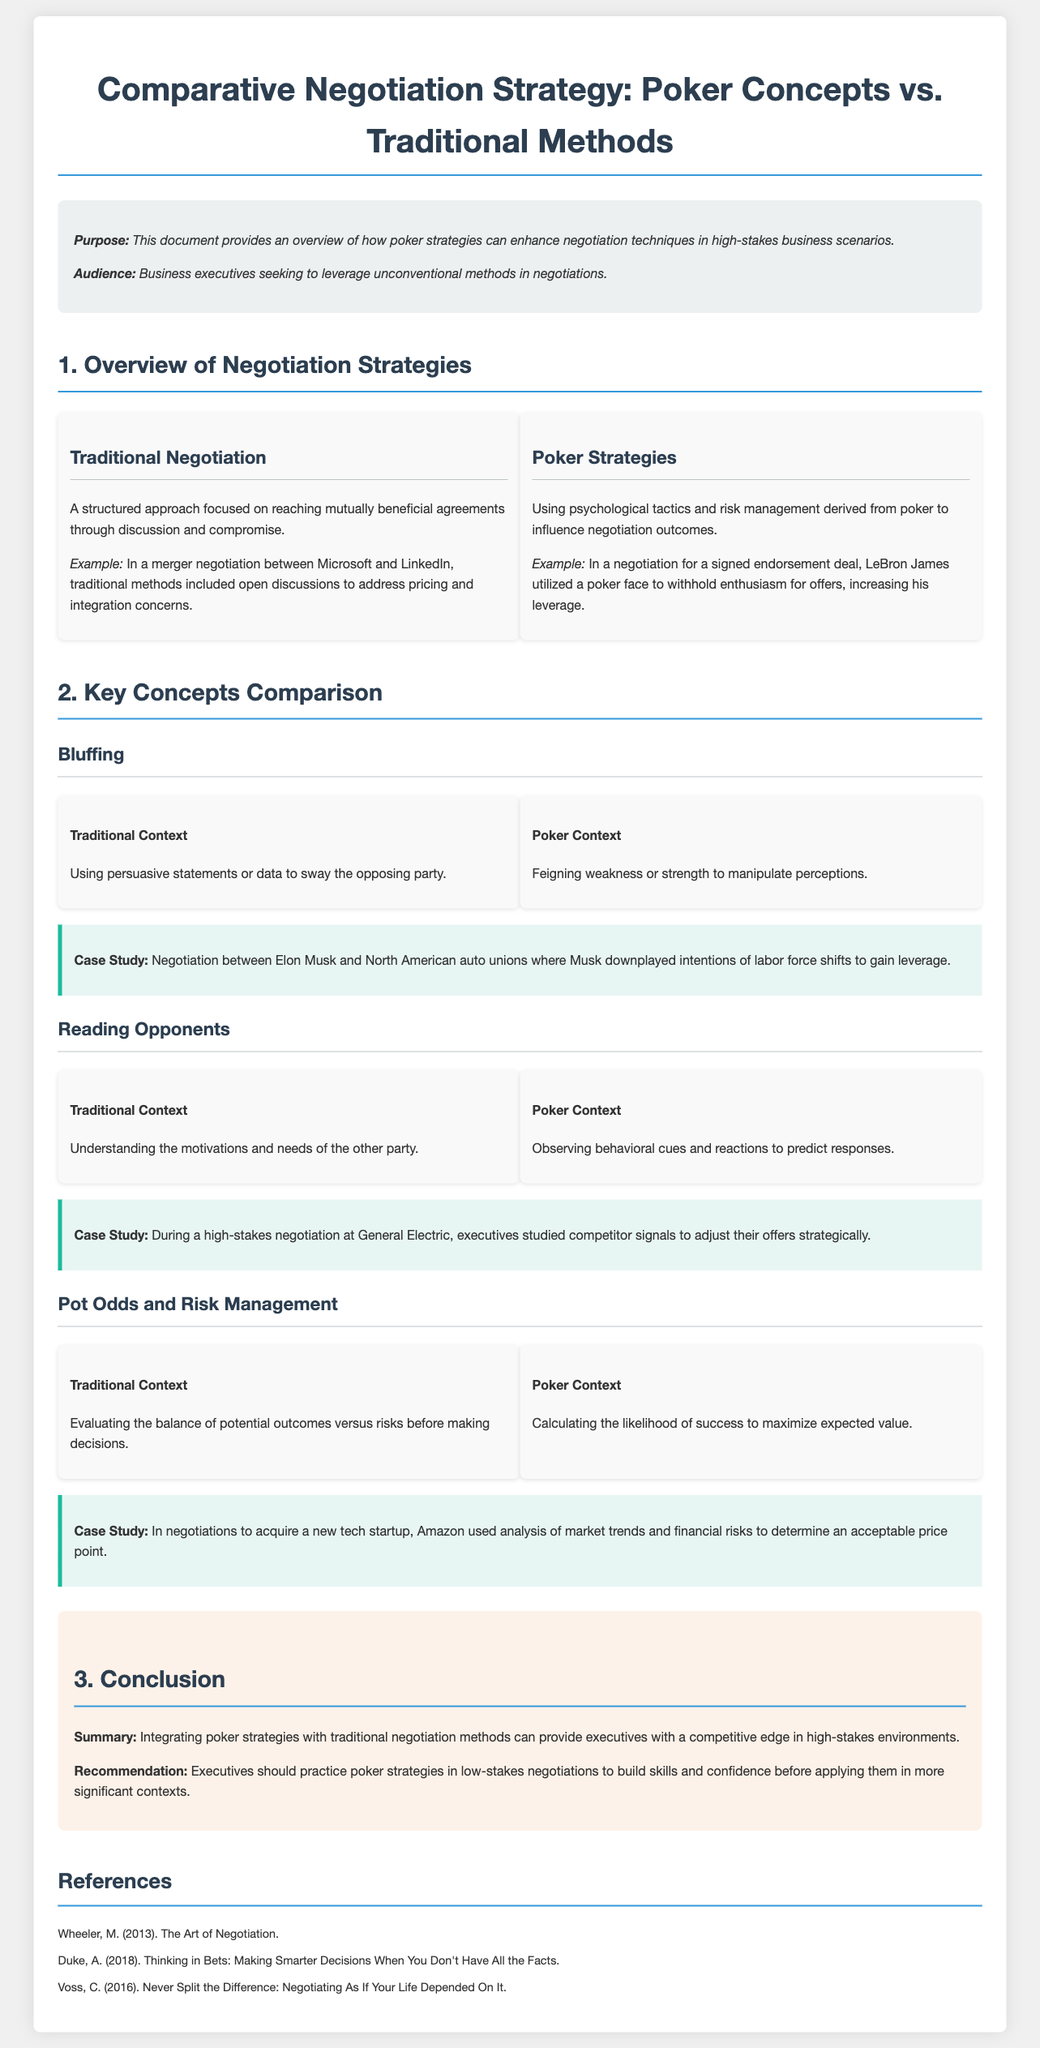What is the purpose of the document? The purpose is clearly stated at the beginning of the document, which is to provide an overview of how poker strategies can enhance negotiation techniques in high-stakes business scenarios.
Answer: Overview of how poker strategies can enhance negotiation techniques Who is the intended audience? The audience section mentions that the document is aimed at business executives seeking to leverage unconventional methods in negotiations.
Answer: Business executives What example is given for traditional negotiation? The document provides an example of a merger negotiation between Microsoft and LinkedIn as a traditional negotiation context.
Answer: Merger negotiation between Microsoft and LinkedIn What psychological tactic is referred to in the poker context? The poker context section describes "bluffing" as a tactic, which involves feigning weakness or strength to manipulate perceptions.
Answer: Bluffing What is the case study example relating to reading opponents? The case study on reading opponents references a high-stakes negotiation at General Electric, where executives studied competitor signals.
Answer: General Electric What recommendation does the document provide to executives? The recommendation section encourages executives to practice poker strategies in low-stakes negotiations to build skills and confidence.
Answer: Practice in low-stakes negotiations How many case studies are included in the document? By counting the case study sections, it can be determined that there are three case studies included.
Answer: Three What aspect of negotiation does "pot odds and risk management" fall under? The document categorizes "pot odds and risk management" under key concepts comparison, indicating it's part of the negotiation strategies being analyzed.
Answer: Key concepts comparison What is the summary statement given in the conclusion? The conclusion summarizes that integrating poker strategies with traditional negotiation methods can provide executives with a competitive edge in high-stakes environments.
Answer: Competitive edge in high-stakes environments 